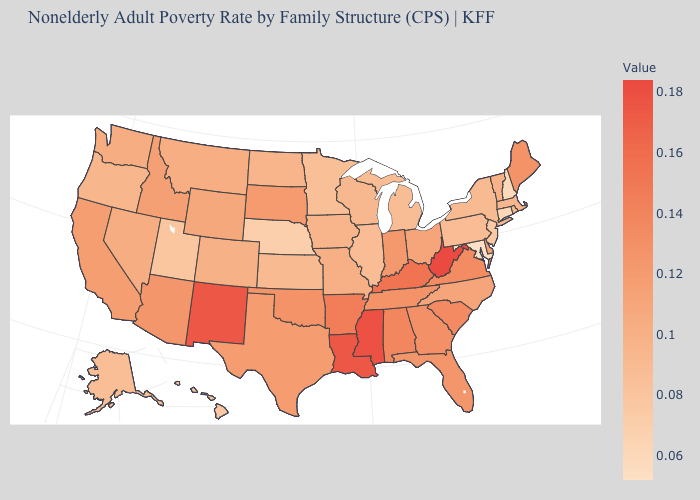Does West Virginia have the highest value in the USA?
Be succinct. Yes. Among the states that border Oklahoma , does New Mexico have the highest value?
Give a very brief answer. Yes. Which states have the lowest value in the USA?
Keep it brief. Maryland. Does Ohio have a lower value than Kentucky?
Write a very short answer. Yes. Does Indiana have the highest value in the MidWest?
Quick response, please. Yes. Among the states that border New Hampshire , which have the highest value?
Give a very brief answer. Maine. Which states have the lowest value in the West?
Keep it brief. Hawaii. Which states hav the highest value in the MidWest?
Quick response, please. Indiana. 